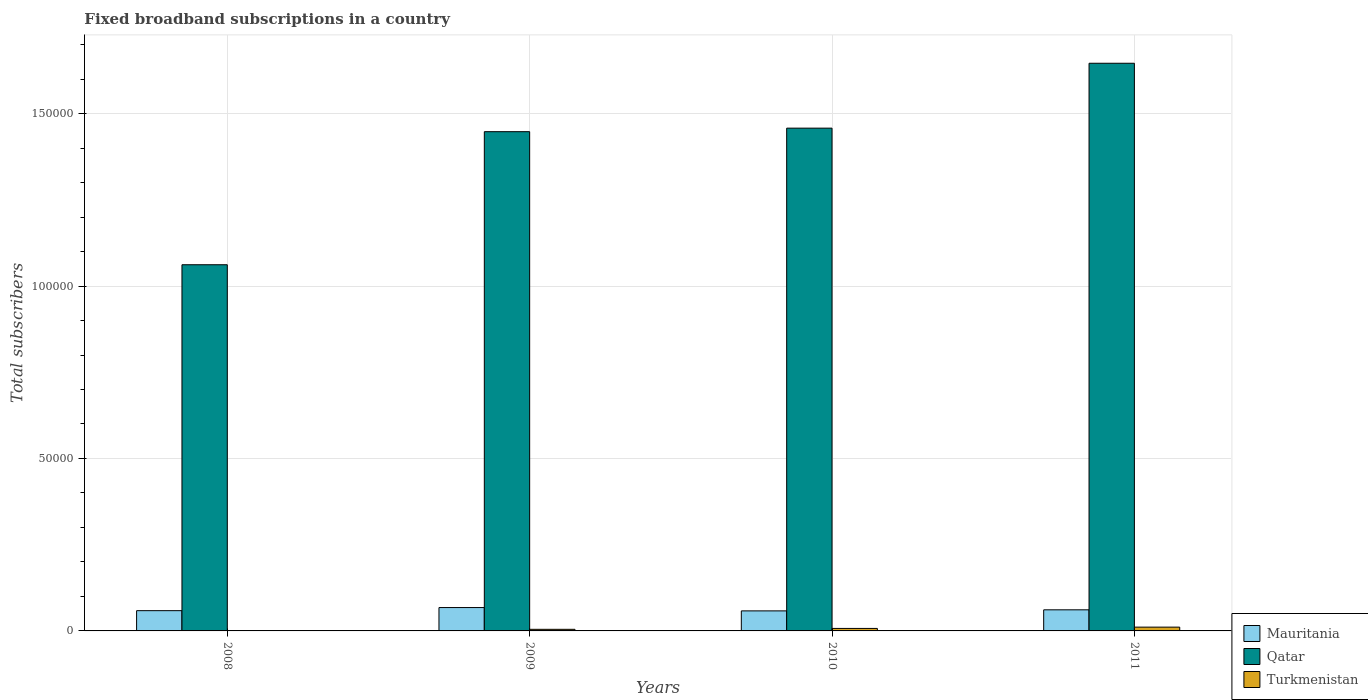How many different coloured bars are there?
Give a very brief answer. 3. How many groups of bars are there?
Your answer should be very brief. 4. Are the number of bars per tick equal to the number of legend labels?
Make the answer very short. Yes. What is the label of the 1st group of bars from the left?
Provide a succinct answer. 2008. In how many cases, is the number of bars for a given year not equal to the number of legend labels?
Provide a short and direct response. 0. What is the number of broadband subscriptions in Mauritania in 2008?
Your response must be concise. 5876. Across all years, what is the maximum number of broadband subscriptions in Mauritania?
Ensure brevity in your answer.  6775. Across all years, what is the minimum number of broadband subscriptions in Qatar?
Give a very brief answer. 1.06e+05. What is the total number of broadband subscriptions in Qatar in the graph?
Provide a succinct answer. 5.61e+05. What is the difference between the number of broadband subscriptions in Mauritania in 2009 and that in 2011?
Offer a terse response. 655. What is the difference between the number of broadband subscriptions in Turkmenistan in 2010 and the number of broadband subscriptions in Mauritania in 2009?
Provide a short and direct response. -6052. What is the average number of broadband subscriptions in Qatar per year?
Keep it short and to the point. 1.40e+05. In the year 2008, what is the difference between the number of broadband subscriptions in Turkmenistan and number of broadband subscriptions in Mauritania?
Your answer should be very brief. -5801. In how many years, is the number of broadband subscriptions in Mauritania greater than 100000?
Make the answer very short. 0. What is the ratio of the number of broadband subscriptions in Turkmenistan in 2009 to that in 2011?
Your answer should be compact. 0.42. What is the difference between the highest and the second highest number of broadband subscriptions in Mauritania?
Give a very brief answer. 655. What is the difference between the highest and the lowest number of broadband subscriptions in Mauritania?
Ensure brevity in your answer.  966. In how many years, is the number of broadband subscriptions in Mauritania greater than the average number of broadband subscriptions in Mauritania taken over all years?
Provide a succinct answer. 1. Is the sum of the number of broadband subscriptions in Turkmenistan in 2008 and 2011 greater than the maximum number of broadband subscriptions in Qatar across all years?
Provide a succinct answer. No. What does the 3rd bar from the left in 2011 represents?
Offer a terse response. Turkmenistan. What does the 1st bar from the right in 2009 represents?
Make the answer very short. Turkmenistan. Is it the case that in every year, the sum of the number of broadband subscriptions in Turkmenistan and number of broadband subscriptions in Qatar is greater than the number of broadband subscriptions in Mauritania?
Your answer should be very brief. Yes. How many bars are there?
Your answer should be very brief. 12. What is the difference between two consecutive major ticks on the Y-axis?
Your answer should be very brief. 5.00e+04. Does the graph contain any zero values?
Give a very brief answer. No. Does the graph contain grids?
Your response must be concise. Yes. How are the legend labels stacked?
Your answer should be compact. Vertical. What is the title of the graph?
Give a very brief answer. Fixed broadband subscriptions in a country. What is the label or title of the Y-axis?
Give a very brief answer. Total subscribers. What is the Total subscribers in Mauritania in 2008?
Provide a succinct answer. 5876. What is the Total subscribers of Qatar in 2008?
Offer a terse response. 1.06e+05. What is the Total subscribers of Mauritania in 2009?
Provide a short and direct response. 6775. What is the Total subscribers in Qatar in 2009?
Make the answer very short. 1.45e+05. What is the Total subscribers of Turkmenistan in 2009?
Your response must be concise. 465. What is the Total subscribers of Mauritania in 2010?
Make the answer very short. 5809. What is the Total subscribers of Qatar in 2010?
Provide a short and direct response. 1.46e+05. What is the Total subscribers of Turkmenistan in 2010?
Provide a short and direct response. 723. What is the Total subscribers in Mauritania in 2011?
Give a very brief answer. 6120. What is the Total subscribers in Qatar in 2011?
Give a very brief answer. 1.65e+05. What is the Total subscribers in Turkmenistan in 2011?
Your answer should be compact. 1100. Across all years, what is the maximum Total subscribers in Mauritania?
Your answer should be very brief. 6775. Across all years, what is the maximum Total subscribers of Qatar?
Keep it short and to the point. 1.65e+05. Across all years, what is the maximum Total subscribers of Turkmenistan?
Your answer should be very brief. 1100. Across all years, what is the minimum Total subscribers in Mauritania?
Your response must be concise. 5809. Across all years, what is the minimum Total subscribers in Qatar?
Offer a terse response. 1.06e+05. What is the total Total subscribers of Mauritania in the graph?
Give a very brief answer. 2.46e+04. What is the total Total subscribers of Qatar in the graph?
Provide a succinct answer. 5.61e+05. What is the total Total subscribers in Turkmenistan in the graph?
Give a very brief answer. 2363. What is the difference between the Total subscribers in Mauritania in 2008 and that in 2009?
Make the answer very short. -899. What is the difference between the Total subscribers of Qatar in 2008 and that in 2009?
Provide a succinct answer. -3.86e+04. What is the difference between the Total subscribers in Turkmenistan in 2008 and that in 2009?
Provide a short and direct response. -390. What is the difference between the Total subscribers of Qatar in 2008 and that in 2010?
Your answer should be compact. -3.96e+04. What is the difference between the Total subscribers in Turkmenistan in 2008 and that in 2010?
Give a very brief answer. -648. What is the difference between the Total subscribers in Mauritania in 2008 and that in 2011?
Offer a very short reply. -244. What is the difference between the Total subscribers in Qatar in 2008 and that in 2011?
Give a very brief answer. -5.84e+04. What is the difference between the Total subscribers of Turkmenistan in 2008 and that in 2011?
Your response must be concise. -1025. What is the difference between the Total subscribers of Mauritania in 2009 and that in 2010?
Give a very brief answer. 966. What is the difference between the Total subscribers in Qatar in 2009 and that in 2010?
Provide a succinct answer. -1027. What is the difference between the Total subscribers in Turkmenistan in 2009 and that in 2010?
Your answer should be compact. -258. What is the difference between the Total subscribers in Mauritania in 2009 and that in 2011?
Provide a short and direct response. 655. What is the difference between the Total subscribers of Qatar in 2009 and that in 2011?
Ensure brevity in your answer.  -1.98e+04. What is the difference between the Total subscribers in Turkmenistan in 2009 and that in 2011?
Your answer should be compact. -635. What is the difference between the Total subscribers of Mauritania in 2010 and that in 2011?
Your answer should be compact. -311. What is the difference between the Total subscribers in Qatar in 2010 and that in 2011?
Give a very brief answer. -1.88e+04. What is the difference between the Total subscribers of Turkmenistan in 2010 and that in 2011?
Offer a terse response. -377. What is the difference between the Total subscribers in Mauritania in 2008 and the Total subscribers in Qatar in 2009?
Provide a short and direct response. -1.39e+05. What is the difference between the Total subscribers of Mauritania in 2008 and the Total subscribers of Turkmenistan in 2009?
Your answer should be very brief. 5411. What is the difference between the Total subscribers in Qatar in 2008 and the Total subscribers in Turkmenistan in 2009?
Offer a terse response. 1.06e+05. What is the difference between the Total subscribers in Mauritania in 2008 and the Total subscribers in Qatar in 2010?
Your answer should be very brief. -1.40e+05. What is the difference between the Total subscribers in Mauritania in 2008 and the Total subscribers in Turkmenistan in 2010?
Make the answer very short. 5153. What is the difference between the Total subscribers in Qatar in 2008 and the Total subscribers in Turkmenistan in 2010?
Make the answer very short. 1.05e+05. What is the difference between the Total subscribers of Mauritania in 2008 and the Total subscribers of Qatar in 2011?
Offer a terse response. -1.59e+05. What is the difference between the Total subscribers in Mauritania in 2008 and the Total subscribers in Turkmenistan in 2011?
Your answer should be compact. 4776. What is the difference between the Total subscribers in Qatar in 2008 and the Total subscribers in Turkmenistan in 2011?
Your answer should be compact. 1.05e+05. What is the difference between the Total subscribers in Mauritania in 2009 and the Total subscribers in Qatar in 2010?
Ensure brevity in your answer.  -1.39e+05. What is the difference between the Total subscribers in Mauritania in 2009 and the Total subscribers in Turkmenistan in 2010?
Offer a terse response. 6052. What is the difference between the Total subscribers of Qatar in 2009 and the Total subscribers of Turkmenistan in 2010?
Your answer should be very brief. 1.44e+05. What is the difference between the Total subscribers of Mauritania in 2009 and the Total subscribers of Qatar in 2011?
Provide a short and direct response. -1.58e+05. What is the difference between the Total subscribers in Mauritania in 2009 and the Total subscribers in Turkmenistan in 2011?
Make the answer very short. 5675. What is the difference between the Total subscribers in Qatar in 2009 and the Total subscribers in Turkmenistan in 2011?
Your answer should be compact. 1.44e+05. What is the difference between the Total subscribers of Mauritania in 2010 and the Total subscribers of Qatar in 2011?
Ensure brevity in your answer.  -1.59e+05. What is the difference between the Total subscribers of Mauritania in 2010 and the Total subscribers of Turkmenistan in 2011?
Ensure brevity in your answer.  4709. What is the difference between the Total subscribers of Qatar in 2010 and the Total subscribers of Turkmenistan in 2011?
Give a very brief answer. 1.45e+05. What is the average Total subscribers of Mauritania per year?
Provide a short and direct response. 6145. What is the average Total subscribers in Qatar per year?
Your response must be concise. 1.40e+05. What is the average Total subscribers of Turkmenistan per year?
Offer a terse response. 590.75. In the year 2008, what is the difference between the Total subscribers in Mauritania and Total subscribers in Qatar?
Provide a succinct answer. -1.00e+05. In the year 2008, what is the difference between the Total subscribers in Mauritania and Total subscribers in Turkmenistan?
Give a very brief answer. 5801. In the year 2008, what is the difference between the Total subscribers of Qatar and Total subscribers of Turkmenistan?
Provide a short and direct response. 1.06e+05. In the year 2009, what is the difference between the Total subscribers in Mauritania and Total subscribers in Qatar?
Offer a terse response. -1.38e+05. In the year 2009, what is the difference between the Total subscribers of Mauritania and Total subscribers of Turkmenistan?
Keep it short and to the point. 6310. In the year 2009, what is the difference between the Total subscribers in Qatar and Total subscribers in Turkmenistan?
Your response must be concise. 1.44e+05. In the year 2010, what is the difference between the Total subscribers in Mauritania and Total subscribers in Qatar?
Provide a succinct answer. -1.40e+05. In the year 2010, what is the difference between the Total subscribers in Mauritania and Total subscribers in Turkmenistan?
Give a very brief answer. 5086. In the year 2010, what is the difference between the Total subscribers in Qatar and Total subscribers in Turkmenistan?
Offer a very short reply. 1.45e+05. In the year 2011, what is the difference between the Total subscribers in Mauritania and Total subscribers in Qatar?
Provide a succinct answer. -1.58e+05. In the year 2011, what is the difference between the Total subscribers of Mauritania and Total subscribers of Turkmenistan?
Provide a succinct answer. 5020. In the year 2011, what is the difference between the Total subscribers in Qatar and Total subscribers in Turkmenistan?
Your answer should be very brief. 1.64e+05. What is the ratio of the Total subscribers in Mauritania in 2008 to that in 2009?
Your response must be concise. 0.87. What is the ratio of the Total subscribers in Qatar in 2008 to that in 2009?
Keep it short and to the point. 0.73. What is the ratio of the Total subscribers in Turkmenistan in 2008 to that in 2009?
Provide a succinct answer. 0.16. What is the ratio of the Total subscribers in Mauritania in 2008 to that in 2010?
Your response must be concise. 1.01. What is the ratio of the Total subscribers in Qatar in 2008 to that in 2010?
Provide a short and direct response. 0.73. What is the ratio of the Total subscribers of Turkmenistan in 2008 to that in 2010?
Make the answer very short. 0.1. What is the ratio of the Total subscribers in Mauritania in 2008 to that in 2011?
Your response must be concise. 0.96. What is the ratio of the Total subscribers in Qatar in 2008 to that in 2011?
Ensure brevity in your answer.  0.65. What is the ratio of the Total subscribers in Turkmenistan in 2008 to that in 2011?
Your answer should be very brief. 0.07. What is the ratio of the Total subscribers in Mauritania in 2009 to that in 2010?
Provide a succinct answer. 1.17. What is the ratio of the Total subscribers of Turkmenistan in 2009 to that in 2010?
Provide a short and direct response. 0.64. What is the ratio of the Total subscribers in Mauritania in 2009 to that in 2011?
Your answer should be very brief. 1.11. What is the ratio of the Total subscribers in Qatar in 2009 to that in 2011?
Your answer should be very brief. 0.88. What is the ratio of the Total subscribers in Turkmenistan in 2009 to that in 2011?
Your answer should be compact. 0.42. What is the ratio of the Total subscribers in Mauritania in 2010 to that in 2011?
Provide a succinct answer. 0.95. What is the ratio of the Total subscribers of Qatar in 2010 to that in 2011?
Your answer should be compact. 0.89. What is the ratio of the Total subscribers in Turkmenistan in 2010 to that in 2011?
Your answer should be very brief. 0.66. What is the difference between the highest and the second highest Total subscribers of Mauritania?
Your response must be concise. 655. What is the difference between the highest and the second highest Total subscribers of Qatar?
Give a very brief answer. 1.88e+04. What is the difference between the highest and the second highest Total subscribers in Turkmenistan?
Provide a succinct answer. 377. What is the difference between the highest and the lowest Total subscribers in Mauritania?
Offer a terse response. 966. What is the difference between the highest and the lowest Total subscribers of Qatar?
Your response must be concise. 5.84e+04. What is the difference between the highest and the lowest Total subscribers in Turkmenistan?
Provide a succinct answer. 1025. 